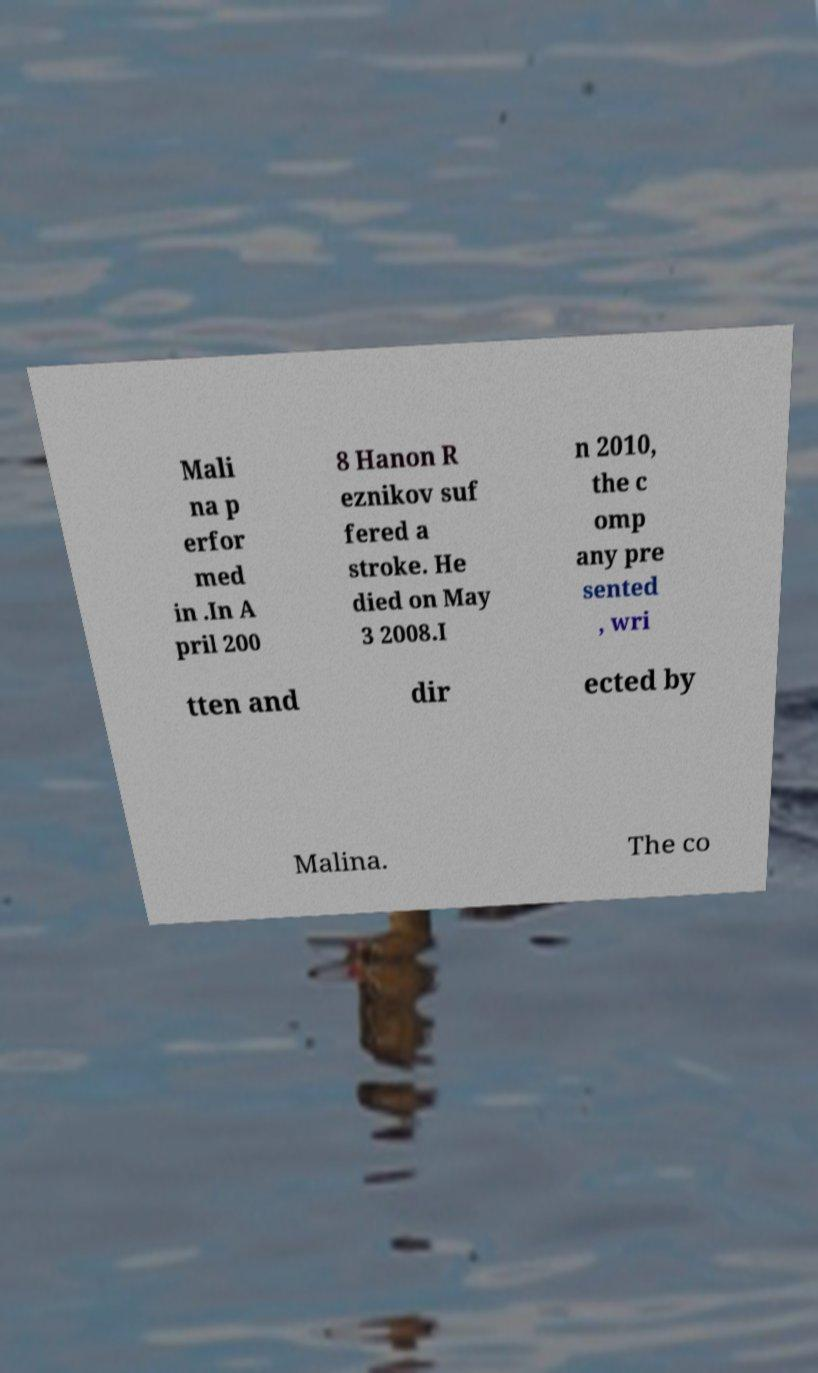There's text embedded in this image that I need extracted. Can you transcribe it verbatim? Mali na p erfor med in .In A pril 200 8 Hanon R eznikov suf fered a stroke. He died on May 3 2008.I n 2010, the c omp any pre sented , wri tten and dir ected by Malina. The co 